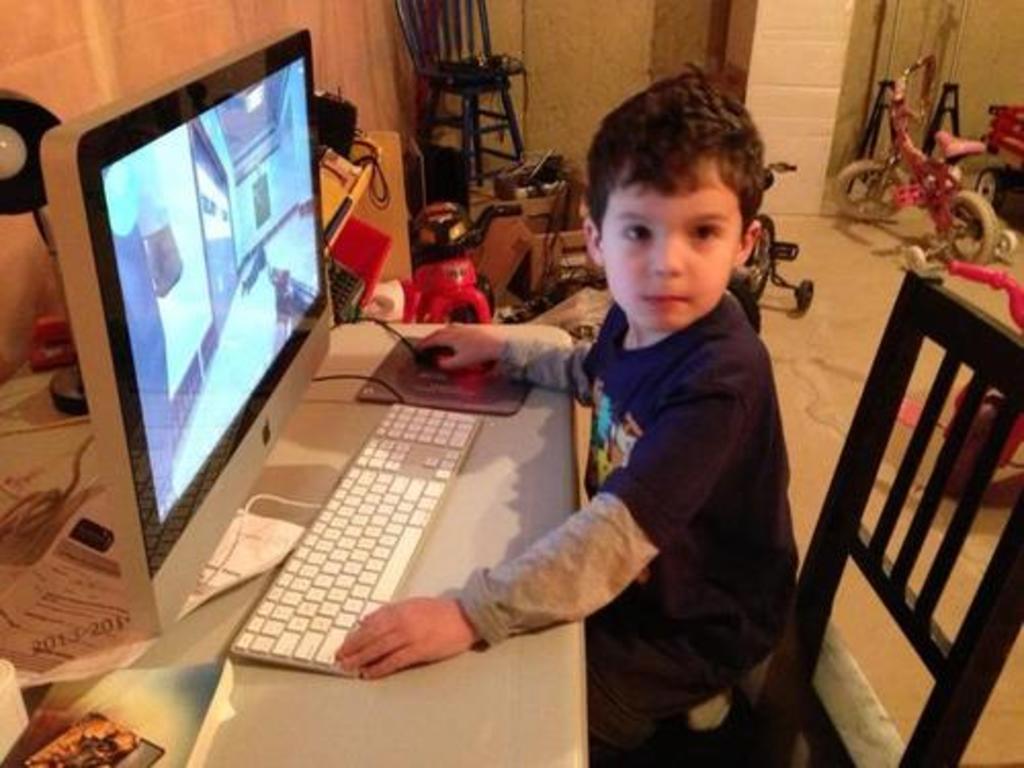Please provide a concise description of this image. This is the small boy sitting on the chair. This is the table with a monitor,keyboard and mouse on the mouse pad. At background I can see toys and a bicycle on the floor. This looks like a chair. Here I can find a lamp behind the monitor,and this is the book placed on the table. 